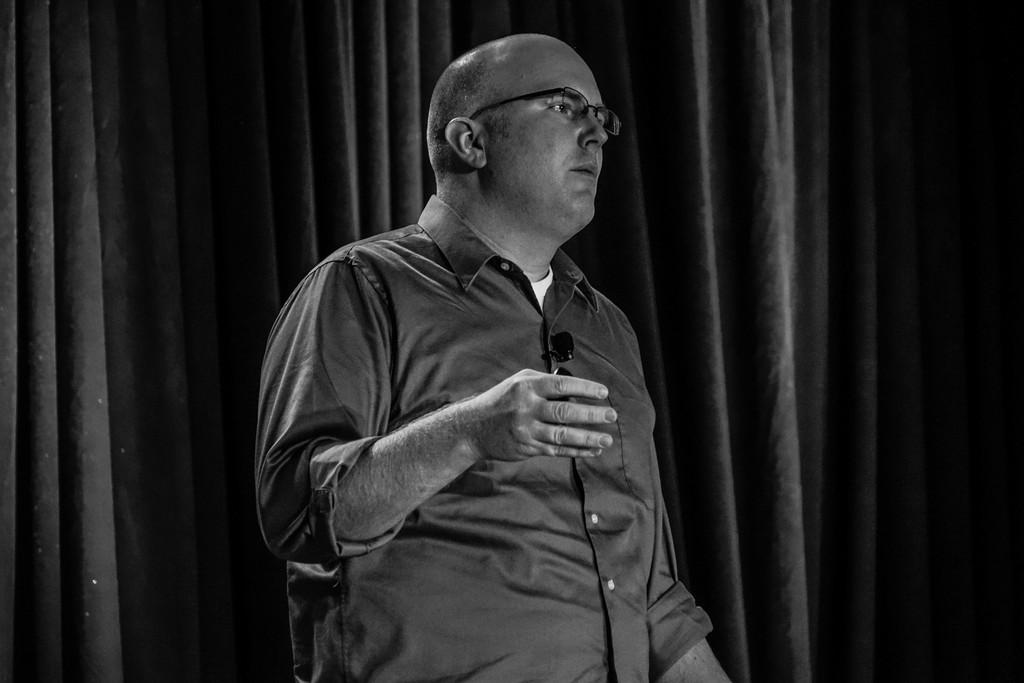Who is present in the image? There is a man in the image. What is the man wearing? The man is wearing a black shirt. What can be seen attached to the man's shirt? There is a mic on the man's shirt. What is visible in the background of the image? There is a black curtain in the background of the image. How does the man's anger affect the organization in the image? There is no indication of the man's anger or an organization in the image. 